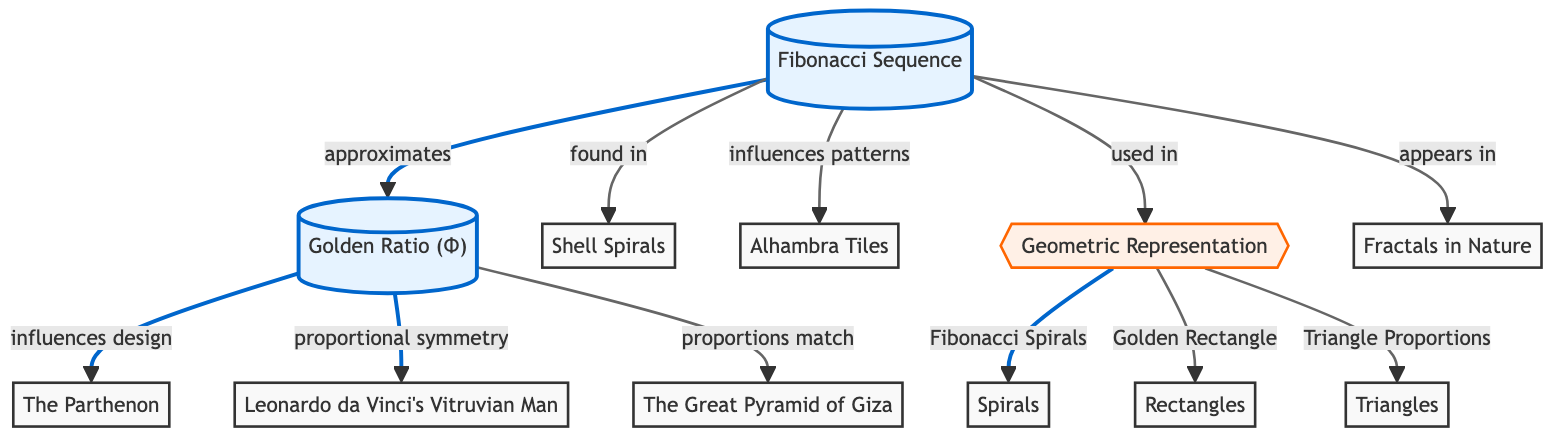What is the first node in the diagram? The first node is labeled "Fibonacci Sequence" which is indicated at the top of the diagram.
Answer: Fibonacci Sequence How many nodes representing specific art or architecture are shown in the diagram? The diagram shows five nodes representing specific art or architecture: The Parthenon, Leonardo da Vinci's Vitruvian Man, Shell Spirals, Alhambra Tiles, and The Great Pyramid of Giza, totaling five nodes.
Answer: 5 What influences the design of The Parthenon? The diagram indicates that the Golden Ratio (Φ) influences the design of The Parthenon, as shown by the directional arrow in the flowchart leading from the Golden Ratio to The Parthenon.
Answer: Golden Ratio (Φ) Which geometric representation corresponds to Fibonacci Spirals? The diagram shows that Fibonacci Spirals are a part of the geometric representation category, specifically linked to Spirals under the Geometric Representation node.
Answer: Spirals What are the three types of geometric representations listed in the diagram? The three types of geometric representations listed are Spirals, Rectangles, and Triangle Proportions, connected to the Geometric Representation node.
Answer: Spirals, Rectangles, Triangles How does the Fibonacci sequence relate to fractals in nature? The diagram shows a direct connection where the Fibonacci sequence appears in fractals in nature, as indicated by the link that flows from the Fibonacci Sequence node to the Fractals in Nature node.
Answer: Appears in What relationship does the Fibonacci sequence have with the patterns in Alhambra Tiles? The Fibonacci sequence influences patterns in Alhambra Tiles, represented by the connecting line from the Fibonacci Sequence to Alhambra Tiles in the diagram.
Answer: Influences patterns What is the relationship between the Golden Ratio and Leonardo da Vinci's Vitruvian Man? The relationship indicates that the Golden Ratio is associated with proportional symmetry in Leonardo da Vinci's Vitruvian Man, as highlighted by the directional flow from the Golden Ratio to that specific artwork.
Answer: Proportional symmetry Which architectural structure matches the proportions of the Golden Ratio? The Great Pyramid of Giza is directly linked to the Golden Ratio as matching proportions, shown by the connection in the flowchart from the Golden Ratio to The Great Pyramid of Giza.
Answer: The Great Pyramid of Giza 